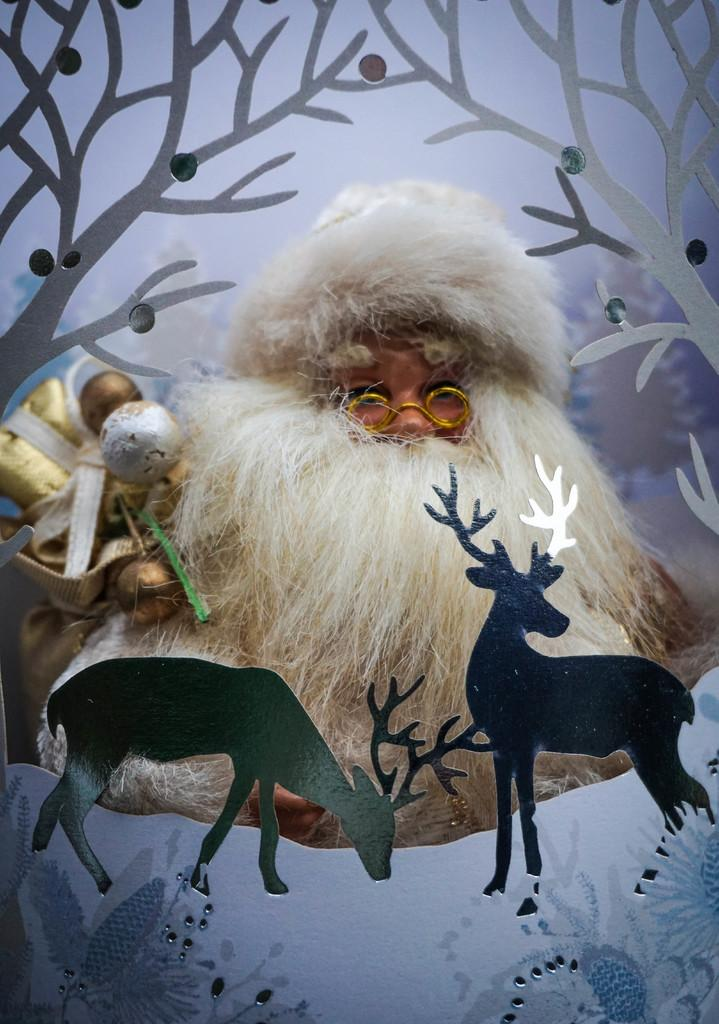What is the main subject of the image? There is a person standing in the center of the image. What is the person wearing in the image? The person is wearing a bag. What can be seen in the foreground of the image? There are toys in the foreground of the image. What is happening in the background of the image? There is there an animation? What type of belief is the person expressing in the image? There is no indication of any belief being expressed in the image; it simply shows a person standing with a bag and toys in the foreground and an animation in the background. Can you see any bees in the image? No, there are no bees present in the image. What type of cart is being used to transport the toys in the image? There is no cart present in the image; the toys are simply in the foreground. 